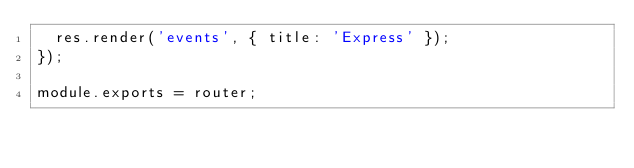Convert code to text. <code><loc_0><loc_0><loc_500><loc_500><_JavaScript_>  res.render('events', { title: 'Express' });
});

module.exports = router;
</code> 